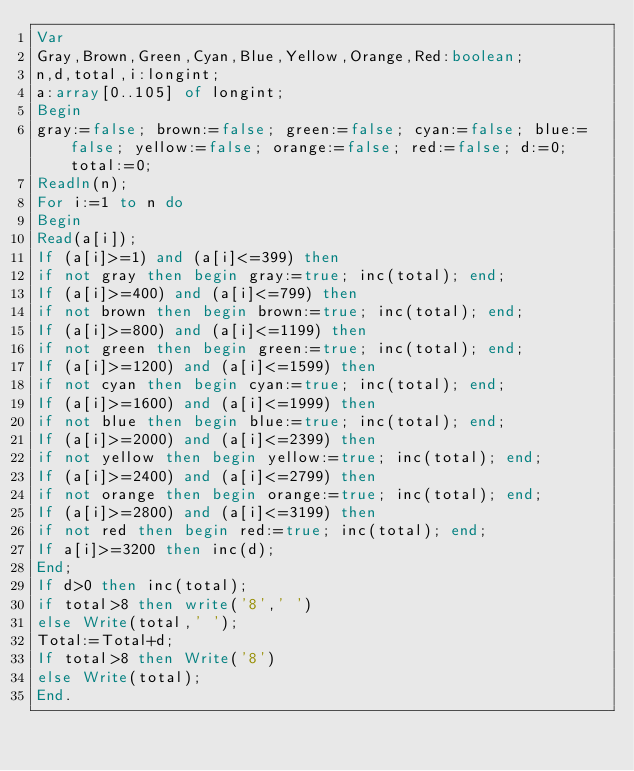Convert code to text. <code><loc_0><loc_0><loc_500><loc_500><_Pascal_>Var
Gray,Brown,Green,Cyan,Blue,Yellow,Orange,Red:boolean;
n,d,total,i:longint;
a:array[0..105] of longint;
Begin
gray:=false; brown:=false; green:=false; cyan:=false; blue:=false; yellow:=false; orange:=false; red:=false; d:=0; total:=0;
Readln(n);
For i:=1 to n do
Begin
Read(a[i]);
If (a[i]>=1) and (a[i]<=399) then 
if not gray then begin gray:=true; inc(total); end;
If (a[i]>=400) and (a[i]<=799) then
if not brown then begin brown:=true; inc(total); end;
If (a[i]>=800) and (a[i]<=1199) then 
if not green then begin green:=true; inc(total); end;
If (a[i]>=1200) and (a[i]<=1599) then 
if not cyan then begin cyan:=true; inc(total); end;
If (a[i]>=1600) and (a[i]<=1999) then 
if not blue then begin blue:=true; inc(total); end;
If (a[i]>=2000) and (a[i]<=2399) then 
if not yellow then begin yellow:=true; inc(total); end;
If (a[i]>=2400) and (a[i]<=2799) then 
if not orange then begin orange:=true; inc(total); end;
If (a[i]>=2800) and (a[i]<=3199) then 
if not red then begin red:=true; inc(total); end;
If a[i]>=3200 then inc(d);
End;
If d>0 then inc(total);
if total>8 then write('8',' ')
else Write(total,' ');
Total:=Total+d;
If total>8 then Write('8')
else Write(total);
End.</code> 